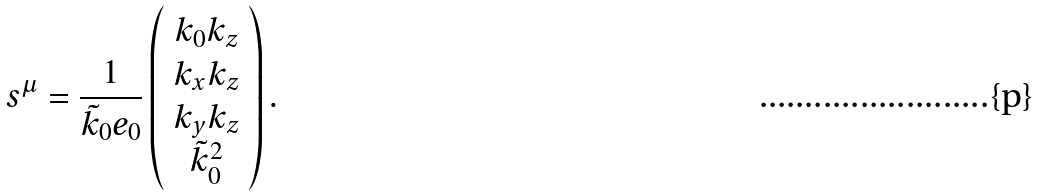<formula> <loc_0><loc_0><loc_500><loc_500>s ^ { \mu } = \frac { 1 } { \tilde { k } _ { 0 } e _ { 0 } } \left ( \begin{array} { c } k _ { 0 } k _ { z } \\ k _ { x } k _ { z } \\ k _ { y } k _ { z } \\ \tilde { k } _ { 0 } ^ { 2 } \end{array} \right ) .</formula> 